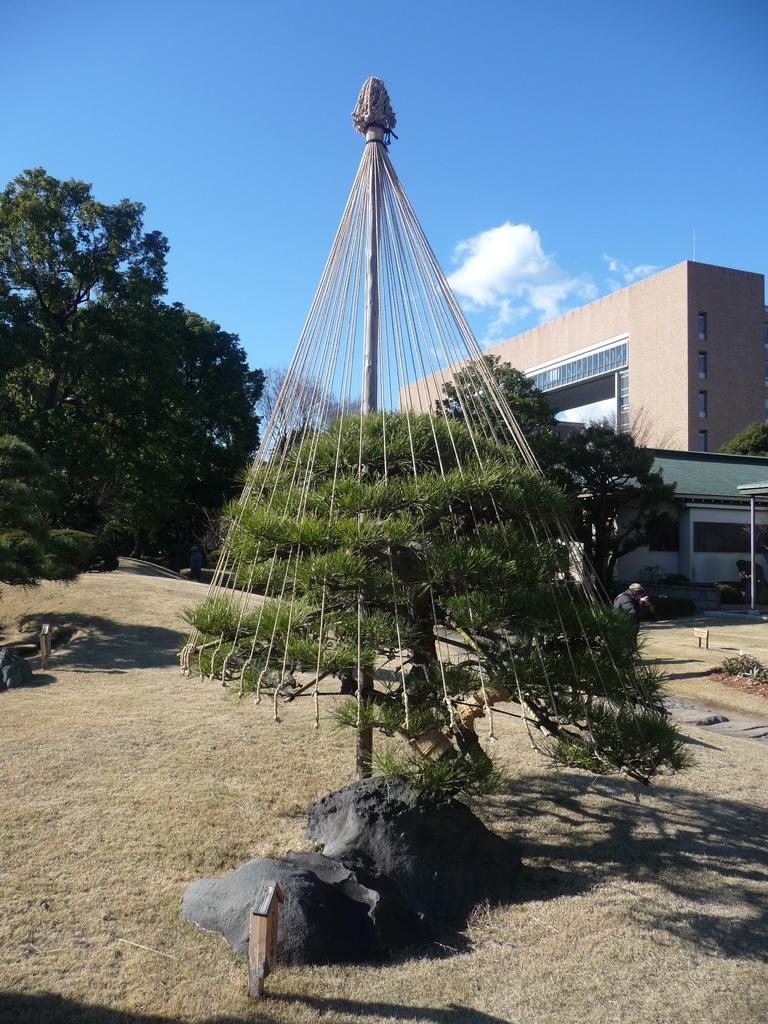Describe this image in one or two sentences. In the image we can see there is an umbrella kept on the ground. Behind there are buildings and there are trees. 